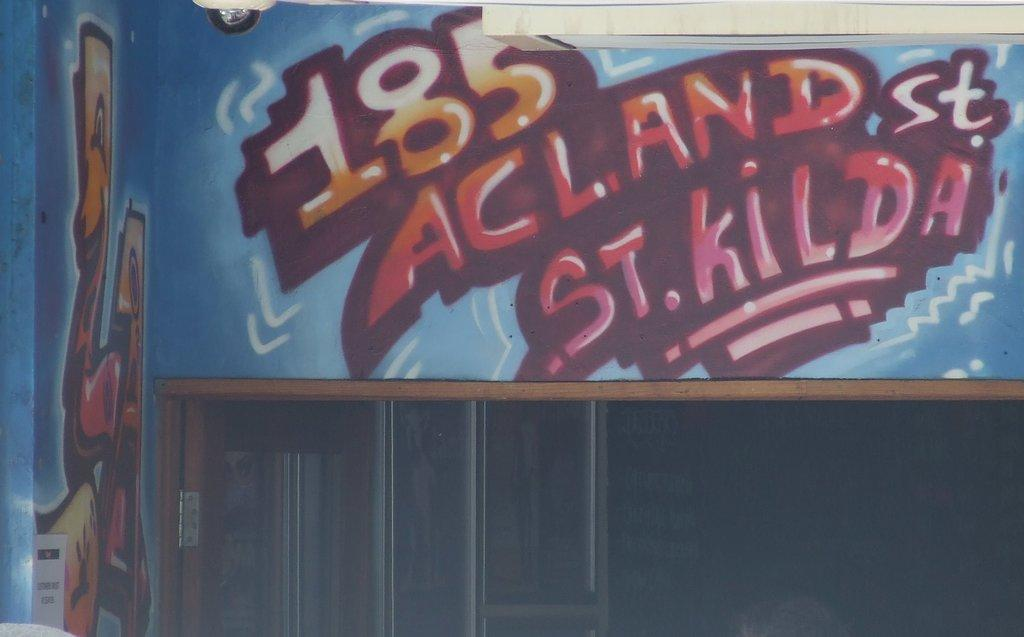<image>
Present a compact description of the photo's key features. Graffiti image with a address on a back wall or a billboard it includes orange and blue, 